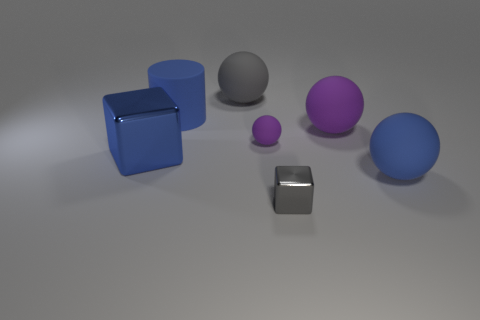Subtract all blue spheres. How many spheres are left? 3 Subtract 1 spheres. How many spheres are left? 3 Subtract all small purple matte spheres. How many spheres are left? 3 Subtract all green balls. Subtract all yellow cylinders. How many balls are left? 4 Add 1 large green rubber blocks. How many objects exist? 8 Subtract all cylinders. How many objects are left? 6 Add 3 big purple matte things. How many big purple matte things exist? 4 Subtract 1 blue cylinders. How many objects are left? 6 Subtract all blue rubber balls. Subtract all large cubes. How many objects are left? 5 Add 3 big gray things. How many big gray things are left? 4 